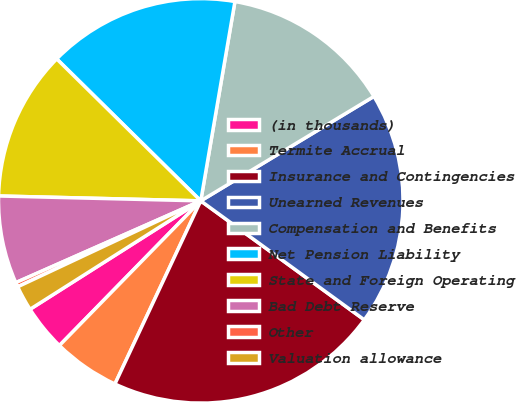Convert chart. <chart><loc_0><loc_0><loc_500><loc_500><pie_chart><fcel>(in thousands)<fcel>Termite Accrual<fcel>Insurance and Contingencies<fcel>Unearned Revenues<fcel>Compensation and Benefits<fcel>Net Pension Liability<fcel>State and Foreign Operating<fcel>Bad Debt Reserve<fcel>Other<fcel>Valuation allowance<nl><fcel>3.68%<fcel>5.34%<fcel>21.97%<fcel>18.65%<fcel>13.66%<fcel>15.32%<fcel>12.0%<fcel>7.01%<fcel>0.36%<fcel>2.02%<nl></chart> 